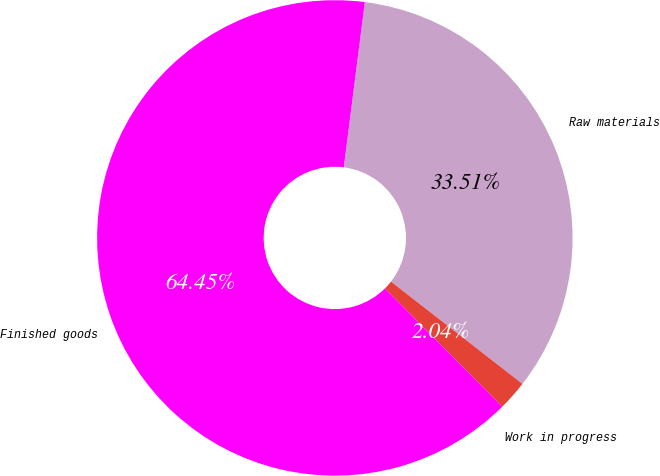<chart> <loc_0><loc_0><loc_500><loc_500><pie_chart><fcel>Raw materials<fcel>Work in progress<fcel>Finished goods<nl><fcel>33.51%<fcel>2.04%<fcel>64.45%<nl></chart> 